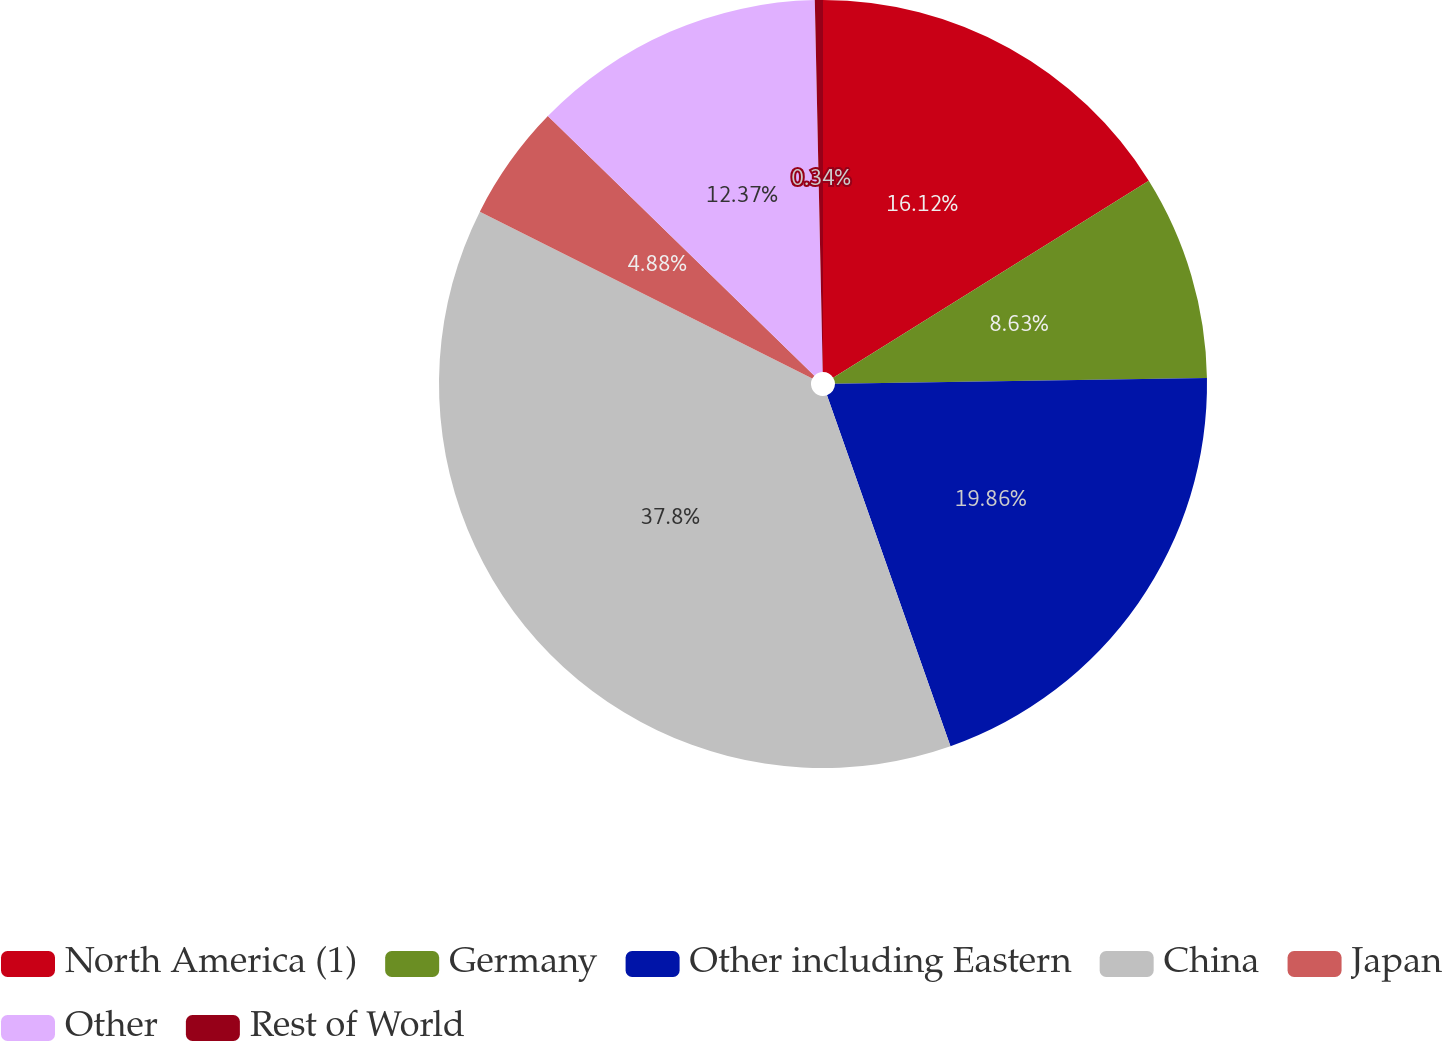Convert chart. <chart><loc_0><loc_0><loc_500><loc_500><pie_chart><fcel>North America (1)<fcel>Germany<fcel>Other including Eastern<fcel>China<fcel>Japan<fcel>Other<fcel>Rest of World<nl><fcel>16.12%<fcel>8.63%<fcel>19.86%<fcel>37.79%<fcel>4.88%<fcel>12.37%<fcel>0.34%<nl></chart> 